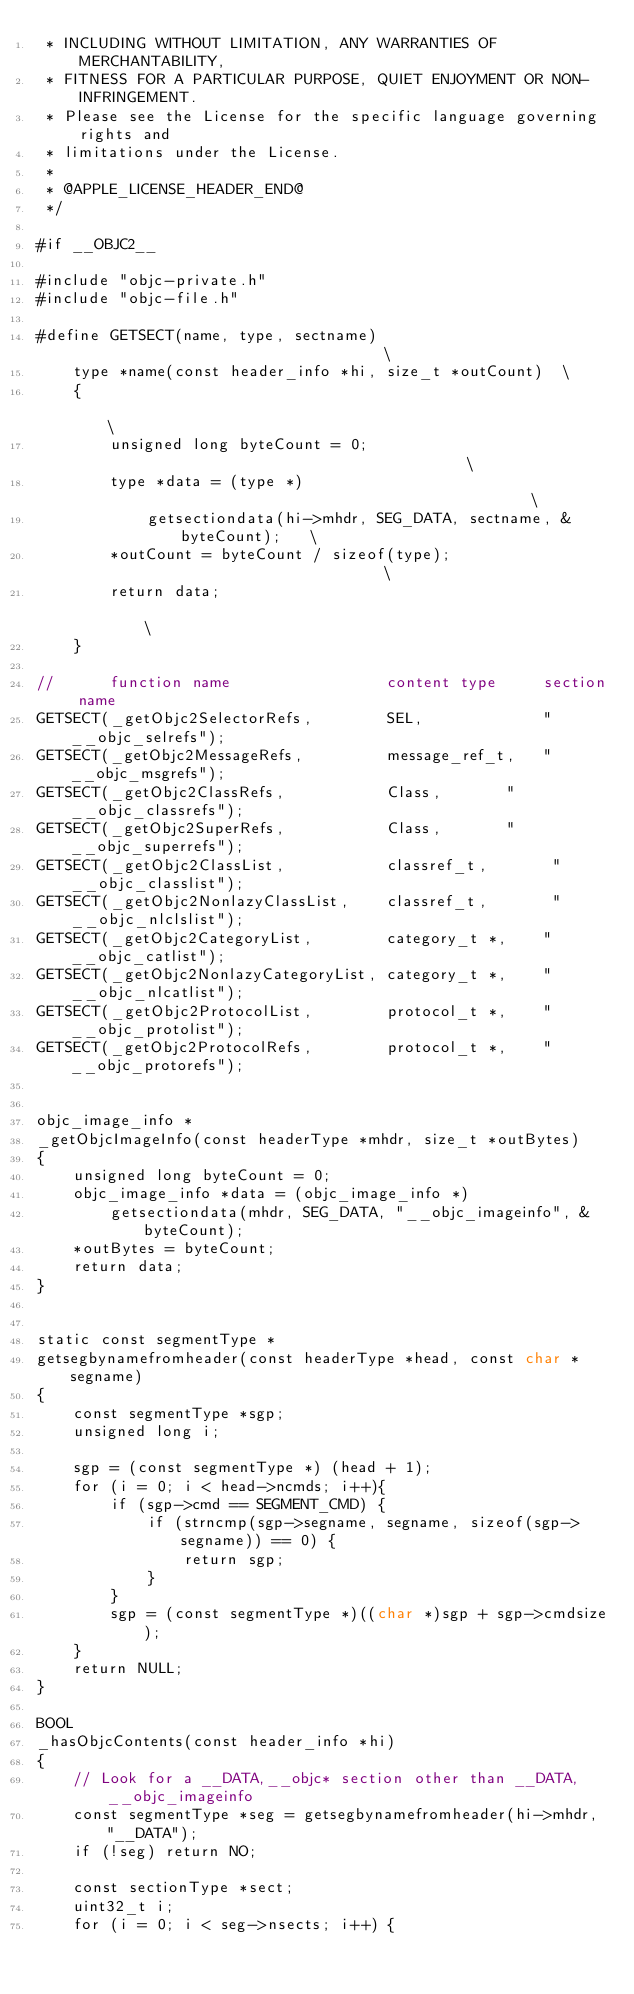<code> <loc_0><loc_0><loc_500><loc_500><_ObjectiveC_> * INCLUDING WITHOUT LIMITATION, ANY WARRANTIES OF MERCHANTABILITY,
 * FITNESS FOR A PARTICULAR PURPOSE, QUIET ENJOYMENT OR NON-INFRINGEMENT.
 * Please see the License for the specific language governing rights and
 * limitations under the License.
 * 
 * @APPLE_LICENSE_HEADER_END@
 */

#if __OBJC2__

#include "objc-private.h"
#include "objc-file.h"

#define GETSECT(name, type, sectname)                                   \
    type *name(const header_info *hi, size_t *outCount)  \
    {                                                                   \
        unsigned long byteCount = 0;                                    \
        type *data = (type *)                                           \
            getsectiondata(hi->mhdr, SEG_DATA, sectname, &byteCount);   \
        *outCount = byteCount / sizeof(type);                           \
        return data;                                                    \
    }

//      function name                 content type     section name
GETSECT(_getObjc2SelectorRefs,        SEL,             "__objc_selrefs"); 
GETSECT(_getObjc2MessageRefs,         message_ref_t,   "__objc_msgrefs"); 
GETSECT(_getObjc2ClassRefs,           Class,       "__objc_classrefs");
GETSECT(_getObjc2SuperRefs,           Class,       "__objc_superrefs");
GETSECT(_getObjc2ClassList,           classref_t,       "__objc_classlist");
GETSECT(_getObjc2NonlazyClassList,    classref_t,       "__objc_nlclslist");
GETSECT(_getObjc2CategoryList,        category_t *,    "__objc_catlist");
GETSECT(_getObjc2NonlazyCategoryList, category_t *,    "__objc_nlcatlist");
GETSECT(_getObjc2ProtocolList,        protocol_t *,    "__objc_protolist");
GETSECT(_getObjc2ProtocolRefs,        protocol_t *,    "__objc_protorefs");


objc_image_info *
_getObjcImageInfo(const headerType *mhdr, size_t *outBytes)
{
    unsigned long byteCount = 0;
    objc_image_info *data = (objc_image_info *)
        getsectiondata(mhdr, SEG_DATA, "__objc_imageinfo", &byteCount);
    *outBytes = byteCount;
    return data;
}


static const segmentType *
getsegbynamefromheader(const headerType *head, const char *segname)
{
    const segmentType *sgp;
    unsigned long i;
    
    sgp = (const segmentType *) (head + 1);
    for (i = 0; i < head->ncmds; i++){
        if (sgp->cmd == SEGMENT_CMD) {
            if (strncmp(sgp->segname, segname, sizeof(sgp->segname)) == 0) {
                return sgp;
            }
        }
        sgp = (const segmentType *)((char *)sgp + sgp->cmdsize);
    }
    return NULL;
}

BOOL
_hasObjcContents(const header_info *hi)
{
    // Look for a __DATA,__objc* section other than __DATA,__objc_imageinfo
    const segmentType *seg = getsegbynamefromheader(hi->mhdr, "__DATA");
    if (!seg) return NO;

    const sectionType *sect;
    uint32_t i;
    for (i = 0; i < seg->nsects; i++) {</code> 